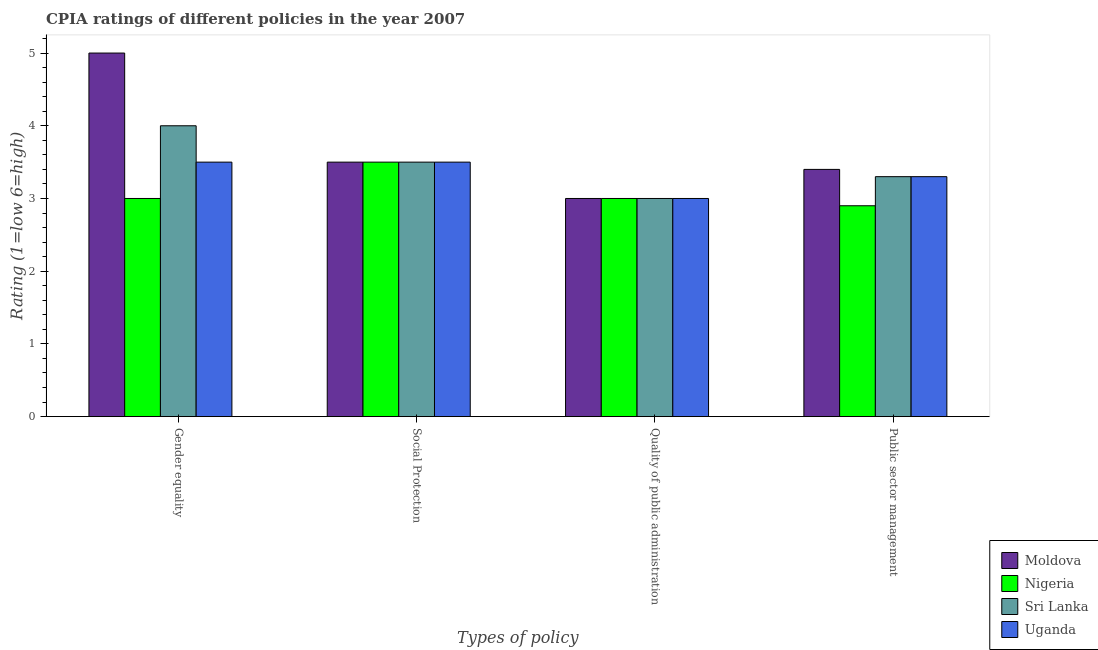How many different coloured bars are there?
Provide a short and direct response. 4. How many groups of bars are there?
Your response must be concise. 4. Are the number of bars on each tick of the X-axis equal?
Keep it short and to the point. Yes. How many bars are there on the 3rd tick from the right?
Provide a short and direct response. 4. What is the label of the 1st group of bars from the left?
Provide a succinct answer. Gender equality. What is the cpia rating of quality of public administration in Sri Lanka?
Give a very brief answer. 3. Across all countries, what is the maximum cpia rating of quality of public administration?
Keep it short and to the point. 3. Across all countries, what is the minimum cpia rating of social protection?
Offer a terse response. 3.5. In which country was the cpia rating of quality of public administration maximum?
Your response must be concise. Moldova. In which country was the cpia rating of social protection minimum?
Offer a very short reply. Moldova. What is the difference between the cpia rating of quality of public administration in Uganda and the cpia rating of gender equality in Nigeria?
Offer a terse response. 0. What is the average cpia rating of social protection per country?
Give a very brief answer. 3.5. In how many countries, is the cpia rating of social protection greater than 2.2 ?
Offer a terse response. 4. What is the ratio of the cpia rating of gender equality in Uganda to that in Nigeria?
Make the answer very short. 1.17. Is the cpia rating of social protection in Nigeria less than that in Sri Lanka?
Provide a short and direct response. No. Is the difference between the cpia rating of quality of public administration in Moldova and Uganda greater than the difference between the cpia rating of social protection in Moldova and Uganda?
Give a very brief answer. No. What is the difference between the highest and the second highest cpia rating of social protection?
Give a very brief answer. 0. What is the difference between the highest and the lowest cpia rating of social protection?
Make the answer very short. 0. In how many countries, is the cpia rating of public sector management greater than the average cpia rating of public sector management taken over all countries?
Provide a succinct answer. 3. Is it the case that in every country, the sum of the cpia rating of gender equality and cpia rating of public sector management is greater than the sum of cpia rating of quality of public administration and cpia rating of social protection?
Offer a terse response. No. What does the 3rd bar from the left in Gender equality represents?
Keep it short and to the point. Sri Lanka. What does the 1st bar from the right in Social Protection represents?
Offer a terse response. Uganda. Are all the bars in the graph horizontal?
Keep it short and to the point. No. How many countries are there in the graph?
Your answer should be compact. 4. Are the values on the major ticks of Y-axis written in scientific E-notation?
Your response must be concise. No. Does the graph contain grids?
Your response must be concise. No. How are the legend labels stacked?
Your answer should be very brief. Vertical. What is the title of the graph?
Offer a terse response. CPIA ratings of different policies in the year 2007. Does "Trinidad and Tobago" appear as one of the legend labels in the graph?
Keep it short and to the point. No. What is the label or title of the X-axis?
Your response must be concise. Types of policy. What is the label or title of the Y-axis?
Ensure brevity in your answer.  Rating (1=low 6=high). What is the Rating (1=low 6=high) in Moldova in Gender equality?
Offer a very short reply. 5. What is the Rating (1=low 6=high) in Nigeria in Gender equality?
Your answer should be compact. 3. What is the Rating (1=low 6=high) in Nigeria in Social Protection?
Offer a very short reply. 3.5. What is the Rating (1=low 6=high) in Sri Lanka in Social Protection?
Your answer should be compact. 3.5. What is the Rating (1=low 6=high) of Uganda in Social Protection?
Provide a succinct answer. 3.5. What is the Rating (1=low 6=high) of Moldova in Quality of public administration?
Provide a short and direct response. 3. What is the Rating (1=low 6=high) in Nigeria in Quality of public administration?
Keep it short and to the point. 3. What is the Rating (1=low 6=high) in Uganda in Quality of public administration?
Provide a short and direct response. 3. What is the Rating (1=low 6=high) of Moldova in Public sector management?
Give a very brief answer. 3.4. What is the Rating (1=low 6=high) of Sri Lanka in Public sector management?
Provide a succinct answer. 3.3. What is the Rating (1=low 6=high) of Uganda in Public sector management?
Your answer should be compact. 3.3. Across all Types of policy, what is the maximum Rating (1=low 6=high) of Moldova?
Your answer should be very brief. 5. Across all Types of policy, what is the maximum Rating (1=low 6=high) in Nigeria?
Give a very brief answer. 3.5. Across all Types of policy, what is the maximum Rating (1=low 6=high) in Uganda?
Provide a short and direct response. 3.5. Across all Types of policy, what is the minimum Rating (1=low 6=high) in Moldova?
Provide a short and direct response. 3. What is the total Rating (1=low 6=high) of Sri Lanka in the graph?
Provide a succinct answer. 13.8. What is the difference between the Rating (1=low 6=high) of Sri Lanka in Gender equality and that in Social Protection?
Make the answer very short. 0.5. What is the difference between the Rating (1=low 6=high) of Nigeria in Gender equality and that in Quality of public administration?
Keep it short and to the point. 0. What is the difference between the Rating (1=low 6=high) of Moldova in Gender equality and that in Public sector management?
Give a very brief answer. 1.6. What is the difference between the Rating (1=low 6=high) of Sri Lanka in Gender equality and that in Public sector management?
Offer a terse response. 0.7. What is the difference between the Rating (1=low 6=high) in Moldova in Social Protection and that in Public sector management?
Offer a terse response. 0.1. What is the difference between the Rating (1=low 6=high) of Uganda in Social Protection and that in Public sector management?
Provide a succinct answer. 0.2. What is the difference between the Rating (1=low 6=high) in Moldova in Quality of public administration and that in Public sector management?
Your answer should be compact. -0.4. What is the difference between the Rating (1=low 6=high) in Sri Lanka in Quality of public administration and that in Public sector management?
Offer a very short reply. -0.3. What is the difference between the Rating (1=low 6=high) of Uganda in Quality of public administration and that in Public sector management?
Provide a short and direct response. -0.3. What is the difference between the Rating (1=low 6=high) of Moldova in Gender equality and the Rating (1=low 6=high) of Sri Lanka in Social Protection?
Provide a succinct answer. 1.5. What is the difference between the Rating (1=low 6=high) in Nigeria in Gender equality and the Rating (1=low 6=high) in Sri Lanka in Social Protection?
Keep it short and to the point. -0.5. What is the difference between the Rating (1=low 6=high) of Nigeria in Gender equality and the Rating (1=low 6=high) of Uganda in Social Protection?
Provide a succinct answer. -0.5. What is the difference between the Rating (1=low 6=high) of Sri Lanka in Gender equality and the Rating (1=low 6=high) of Uganda in Social Protection?
Offer a terse response. 0.5. What is the difference between the Rating (1=low 6=high) of Moldova in Gender equality and the Rating (1=low 6=high) of Nigeria in Quality of public administration?
Ensure brevity in your answer.  2. What is the difference between the Rating (1=low 6=high) of Moldova in Gender equality and the Rating (1=low 6=high) of Sri Lanka in Quality of public administration?
Offer a very short reply. 2. What is the difference between the Rating (1=low 6=high) of Moldova in Gender equality and the Rating (1=low 6=high) of Nigeria in Public sector management?
Make the answer very short. 2.1. What is the difference between the Rating (1=low 6=high) of Nigeria in Gender equality and the Rating (1=low 6=high) of Uganda in Public sector management?
Keep it short and to the point. -0.3. What is the difference between the Rating (1=low 6=high) of Sri Lanka in Gender equality and the Rating (1=low 6=high) of Uganda in Public sector management?
Provide a succinct answer. 0.7. What is the difference between the Rating (1=low 6=high) of Moldova in Social Protection and the Rating (1=low 6=high) of Sri Lanka in Quality of public administration?
Provide a succinct answer. 0.5. What is the difference between the Rating (1=low 6=high) in Nigeria in Social Protection and the Rating (1=low 6=high) in Sri Lanka in Quality of public administration?
Your answer should be compact. 0.5. What is the difference between the Rating (1=low 6=high) of Nigeria in Social Protection and the Rating (1=low 6=high) of Uganda in Quality of public administration?
Make the answer very short. 0.5. What is the difference between the Rating (1=low 6=high) of Sri Lanka in Social Protection and the Rating (1=low 6=high) of Uganda in Quality of public administration?
Ensure brevity in your answer.  0.5. What is the difference between the Rating (1=low 6=high) of Moldova in Social Protection and the Rating (1=low 6=high) of Nigeria in Public sector management?
Make the answer very short. 0.6. What is the difference between the Rating (1=low 6=high) in Moldova in Social Protection and the Rating (1=low 6=high) in Sri Lanka in Public sector management?
Give a very brief answer. 0.2. What is the difference between the Rating (1=low 6=high) in Moldova in Social Protection and the Rating (1=low 6=high) in Uganda in Public sector management?
Give a very brief answer. 0.2. What is the difference between the Rating (1=low 6=high) in Nigeria in Social Protection and the Rating (1=low 6=high) in Uganda in Public sector management?
Your answer should be very brief. 0.2. What is the difference between the Rating (1=low 6=high) of Moldova in Quality of public administration and the Rating (1=low 6=high) of Uganda in Public sector management?
Provide a short and direct response. -0.3. What is the difference between the Rating (1=low 6=high) in Nigeria in Quality of public administration and the Rating (1=low 6=high) in Sri Lanka in Public sector management?
Provide a succinct answer. -0.3. What is the difference between the Rating (1=low 6=high) in Sri Lanka in Quality of public administration and the Rating (1=low 6=high) in Uganda in Public sector management?
Your answer should be compact. -0.3. What is the average Rating (1=low 6=high) in Moldova per Types of policy?
Your answer should be compact. 3.73. What is the average Rating (1=low 6=high) of Nigeria per Types of policy?
Your response must be concise. 3.1. What is the average Rating (1=low 6=high) of Sri Lanka per Types of policy?
Your response must be concise. 3.45. What is the average Rating (1=low 6=high) of Uganda per Types of policy?
Your response must be concise. 3.33. What is the difference between the Rating (1=low 6=high) in Moldova and Rating (1=low 6=high) in Uganda in Gender equality?
Offer a very short reply. 1.5. What is the difference between the Rating (1=low 6=high) of Nigeria and Rating (1=low 6=high) of Sri Lanka in Gender equality?
Ensure brevity in your answer.  -1. What is the difference between the Rating (1=low 6=high) in Nigeria and Rating (1=low 6=high) in Uganda in Gender equality?
Your answer should be compact. -0.5. What is the difference between the Rating (1=low 6=high) of Sri Lanka and Rating (1=low 6=high) of Uganda in Gender equality?
Make the answer very short. 0.5. What is the difference between the Rating (1=low 6=high) of Moldova and Rating (1=low 6=high) of Nigeria in Social Protection?
Make the answer very short. 0. What is the difference between the Rating (1=low 6=high) of Nigeria and Rating (1=low 6=high) of Uganda in Social Protection?
Give a very brief answer. 0. What is the difference between the Rating (1=low 6=high) of Sri Lanka and Rating (1=low 6=high) of Uganda in Social Protection?
Ensure brevity in your answer.  0. What is the difference between the Rating (1=low 6=high) in Moldova and Rating (1=low 6=high) in Sri Lanka in Quality of public administration?
Offer a very short reply. 0. What is the difference between the Rating (1=low 6=high) in Moldova and Rating (1=low 6=high) in Uganda in Quality of public administration?
Your response must be concise. 0. What is the difference between the Rating (1=low 6=high) in Sri Lanka and Rating (1=low 6=high) in Uganda in Quality of public administration?
Provide a short and direct response. 0. What is the difference between the Rating (1=low 6=high) of Moldova and Rating (1=low 6=high) of Sri Lanka in Public sector management?
Offer a terse response. 0.1. What is the difference between the Rating (1=low 6=high) in Nigeria and Rating (1=low 6=high) in Uganda in Public sector management?
Keep it short and to the point. -0.4. What is the ratio of the Rating (1=low 6=high) in Moldova in Gender equality to that in Social Protection?
Give a very brief answer. 1.43. What is the ratio of the Rating (1=low 6=high) of Nigeria in Gender equality to that in Social Protection?
Keep it short and to the point. 0.86. What is the ratio of the Rating (1=low 6=high) in Uganda in Gender equality to that in Social Protection?
Provide a succinct answer. 1. What is the ratio of the Rating (1=low 6=high) of Moldova in Gender equality to that in Quality of public administration?
Keep it short and to the point. 1.67. What is the ratio of the Rating (1=low 6=high) in Nigeria in Gender equality to that in Quality of public administration?
Ensure brevity in your answer.  1. What is the ratio of the Rating (1=low 6=high) of Sri Lanka in Gender equality to that in Quality of public administration?
Offer a terse response. 1.33. What is the ratio of the Rating (1=low 6=high) of Uganda in Gender equality to that in Quality of public administration?
Provide a succinct answer. 1.17. What is the ratio of the Rating (1=low 6=high) of Moldova in Gender equality to that in Public sector management?
Provide a short and direct response. 1.47. What is the ratio of the Rating (1=low 6=high) of Nigeria in Gender equality to that in Public sector management?
Your response must be concise. 1.03. What is the ratio of the Rating (1=low 6=high) in Sri Lanka in Gender equality to that in Public sector management?
Keep it short and to the point. 1.21. What is the ratio of the Rating (1=low 6=high) of Uganda in Gender equality to that in Public sector management?
Offer a terse response. 1.06. What is the ratio of the Rating (1=low 6=high) in Moldova in Social Protection to that in Quality of public administration?
Offer a very short reply. 1.17. What is the ratio of the Rating (1=low 6=high) in Nigeria in Social Protection to that in Quality of public administration?
Offer a terse response. 1.17. What is the ratio of the Rating (1=low 6=high) in Moldova in Social Protection to that in Public sector management?
Provide a succinct answer. 1.03. What is the ratio of the Rating (1=low 6=high) of Nigeria in Social Protection to that in Public sector management?
Your response must be concise. 1.21. What is the ratio of the Rating (1=low 6=high) of Sri Lanka in Social Protection to that in Public sector management?
Offer a terse response. 1.06. What is the ratio of the Rating (1=low 6=high) in Uganda in Social Protection to that in Public sector management?
Keep it short and to the point. 1.06. What is the ratio of the Rating (1=low 6=high) in Moldova in Quality of public administration to that in Public sector management?
Ensure brevity in your answer.  0.88. What is the ratio of the Rating (1=low 6=high) in Nigeria in Quality of public administration to that in Public sector management?
Your response must be concise. 1.03. What is the ratio of the Rating (1=low 6=high) of Uganda in Quality of public administration to that in Public sector management?
Keep it short and to the point. 0.91. What is the difference between the highest and the second highest Rating (1=low 6=high) in Nigeria?
Offer a terse response. 0.5. What is the difference between the highest and the lowest Rating (1=low 6=high) in Moldova?
Ensure brevity in your answer.  2. 